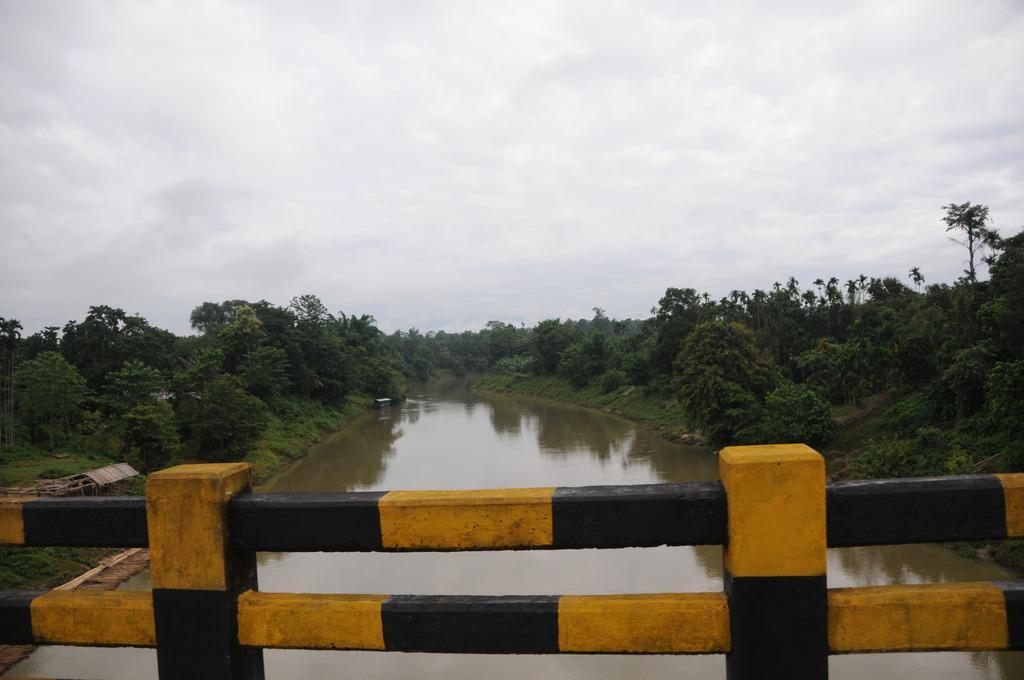Could you give a brief overview of what you see in this image? In the picture we can see a railing which is black and yellow in color and behind it, we can see water and on the other sides of the water we can see grass, plants, trees and in the background we can see a sky with clouds. 